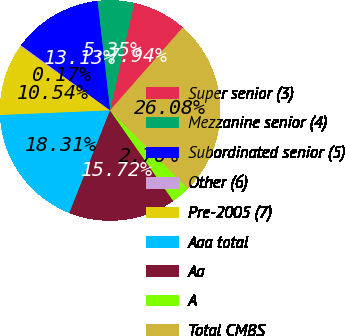<chart> <loc_0><loc_0><loc_500><loc_500><pie_chart><fcel>Super senior (3)<fcel>Mezzanine senior (4)<fcel>Subordinated senior (5)<fcel>Other (6)<fcel>Pre-2005 (7)<fcel>Aaa total<fcel>Aa<fcel>A<fcel>Total CMBS<nl><fcel>7.94%<fcel>5.35%<fcel>13.13%<fcel>0.17%<fcel>10.54%<fcel>18.31%<fcel>15.72%<fcel>2.76%<fcel>26.08%<nl></chart> 